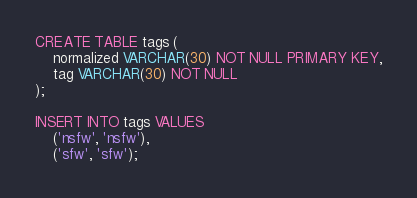<code> <loc_0><loc_0><loc_500><loc_500><_SQL_>
CREATE TABLE tags (
    normalized VARCHAR(30) NOT NULL PRIMARY KEY,
    tag VARCHAR(30) NOT NULL
);

INSERT INTO tags VALUES
    ('nsfw', 'nsfw'),
    ('sfw', 'sfw');</code> 